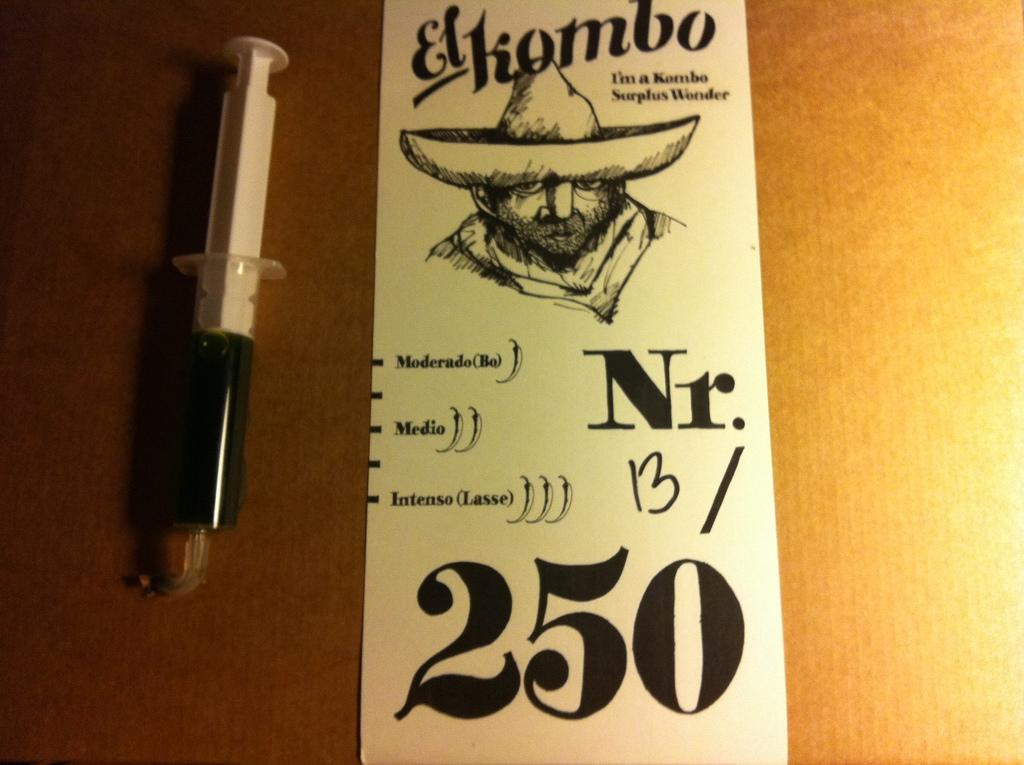What medical instrument is visible in the image? There is a syringe in the image. What else can be seen in the image besides the syringe? There is a paper in the image. What is depicted on the paper? There is a drawing of a person on the paper. Are there any words on the paper? Yes, there is writing on the paper. What type of rings can be seen on the person's fingers in the image? There are no rings visible on the person's fingers in the image, as there is only a drawing of a person on the paper. 